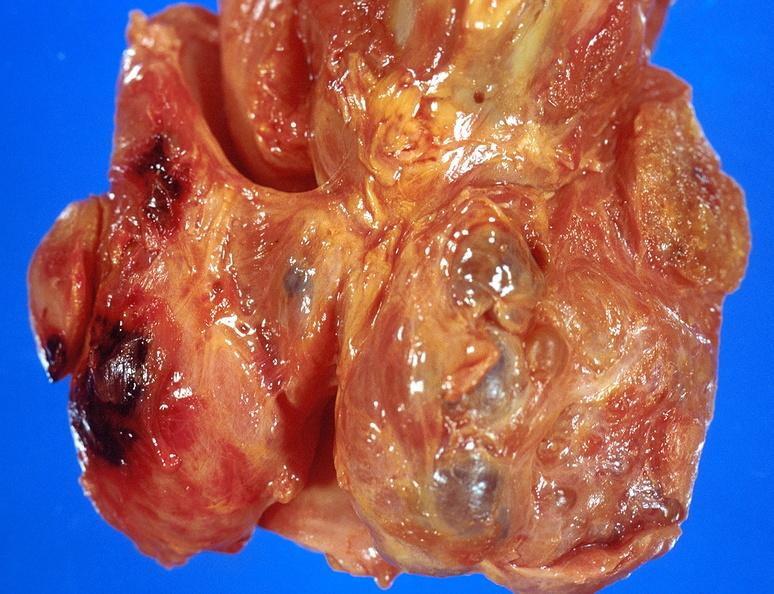what is present?
Answer the question using a single word or phrase. Endocrine 